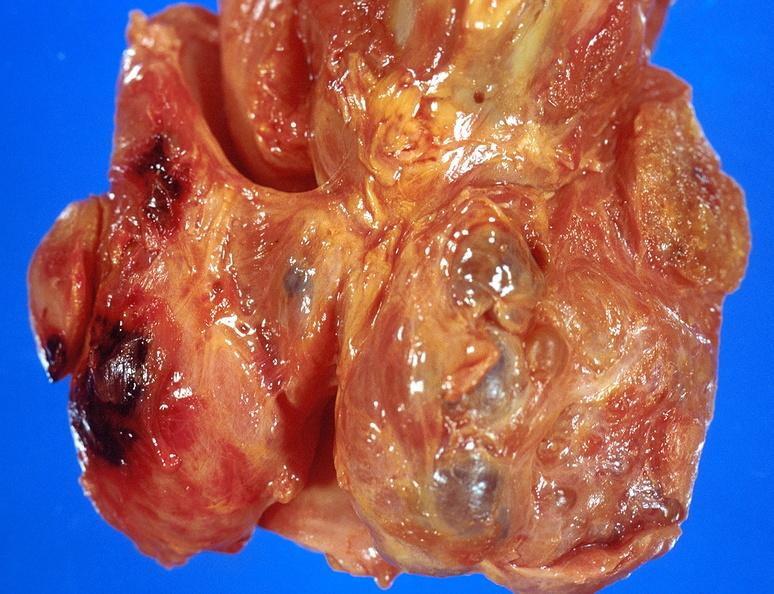what is present?
Answer the question using a single word or phrase. Endocrine 